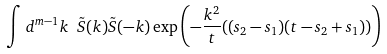Convert formula to latex. <formula><loc_0><loc_0><loc_500><loc_500>\int d ^ { m - 1 } k \ \tilde { S } ( k ) \tilde { S } ( - k ) \exp \left ( - \frac { k ^ { 2 } } { t } ( ( s _ { 2 } - s _ { 1 } ) ( t - s _ { 2 } + s _ { 1 } ) ) \right )</formula> 